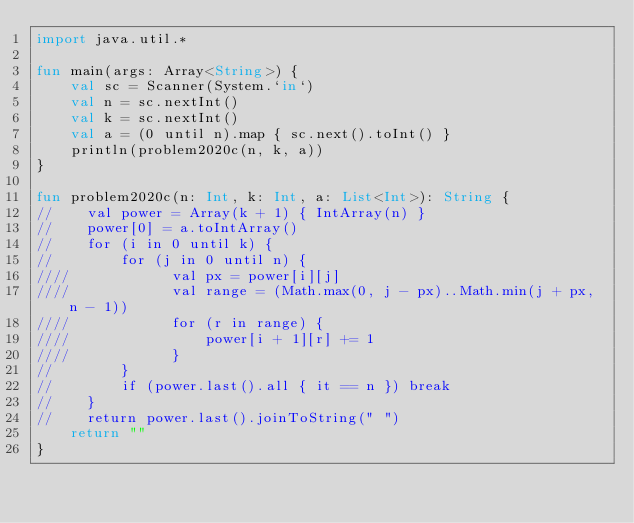Convert code to text. <code><loc_0><loc_0><loc_500><loc_500><_Kotlin_>import java.util.*

fun main(args: Array<String>) {
    val sc = Scanner(System.`in`)
    val n = sc.nextInt()
    val k = sc.nextInt()
    val a = (0 until n).map { sc.next().toInt() }
    println(problem2020c(n, k, a))
}

fun problem2020c(n: Int, k: Int, a: List<Int>): String {
//    val power = Array(k + 1) { IntArray(n) }
//    power[0] = a.toIntArray()
//    for (i in 0 until k) {
//        for (j in 0 until n) {
////            val px = power[i][j]
////            val range = (Math.max(0, j - px)..Math.min(j + px, n - 1))
////            for (r in range) {
////                power[i + 1][r] += 1
////            }
//        }
//        if (power.last().all { it == n }) break
//    }
//    return power.last().joinToString(" ")
    return ""
}</code> 